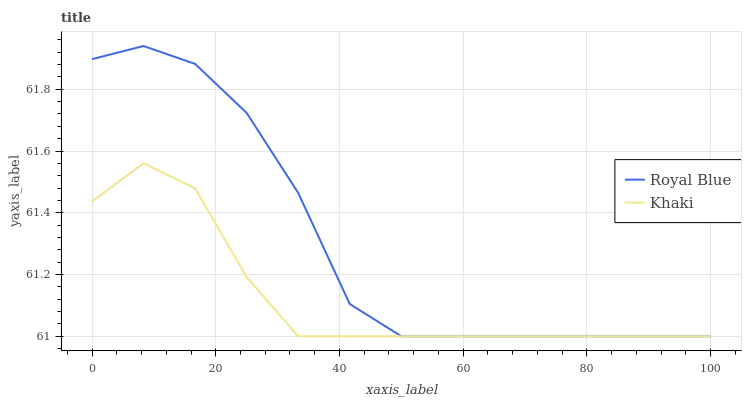Does Khaki have the maximum area under the curve?
Answer yes or no. No. Is Khaki the roughest?
Answer yes or no. No. Does Khaki have the highest value?
Answer yes or no. No. 